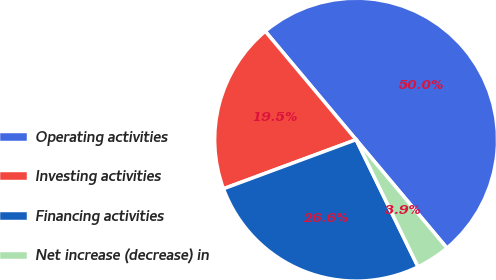Convert chart to OTSL. <chart><loc_0><loc_0><loc_500><loc_500><pie_chart><fcel>Operating activities<fcel>Investing activities<fcel>Financing activities<fcel>Net increase (decrease) in<nl><fcel>50.0%<fcel>19.54%<fcel>26.57%<fcel>3.89%<nl></chart> 